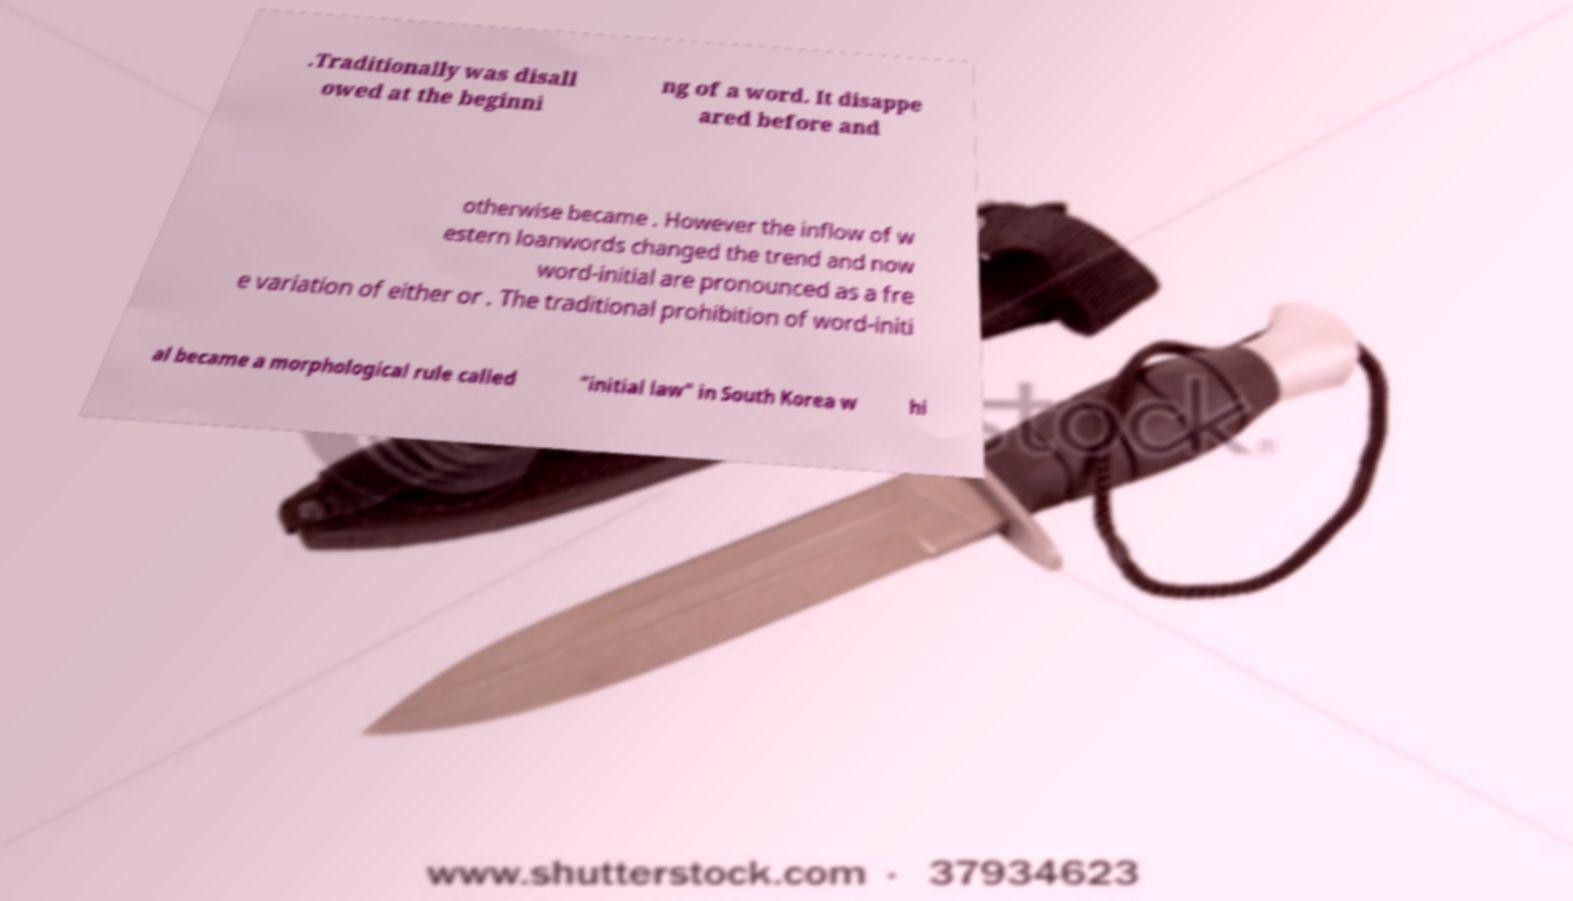I need the written content from this picture converted into text. Can you do that? .Traditionally was disall owed at the beginni ng of a word. It disappe ared before and otherwise became . However the inflow of w estern loanwords changed the trend and now word-initial are pronounced as a fre e variation of either or . The traditional prohibition of word-initi al became a morphological rule called "initial law" in South Korea w hi 